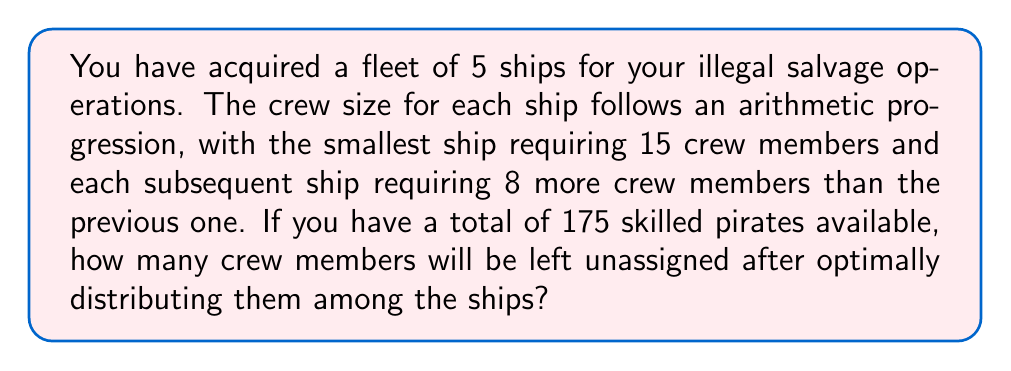Solve this math problem. Let's approach this step-by-step:

1) First, we need to determine the crew size for each ship using the arithmetic progression formula:
   $a_n = a_1 + (n-1)d$
   where $a_1 = 15$ (first term), $d = 8$ (common difference), and $n = 1,2,3,4,5$

2) Calculating crew sizes:
   Ship 1: $a_1 = 15$
   Ship 2: $a_2 = 15 + (2-1)8 = 23$
   Ship 3: $a_3 = 15 + (3-1)8 = 31$
   Ship 4: $a_4 = 15 + (4-1)8 = 39$
   Ship 5: $a_5 = 15 + (5-1)8 = 47$

3) To find the total number of crew members needed, we sum these values:
   $S_n = \frac{n}{2}(a_1 + a_n)$
   where $n = 5$, $a_1 = 15$, and $a_n = a_5 = 47$

4) Plugging in the values:
   $S_5 = \frac{5}{2}(15 + 47) = \frac{5}{2}(62) = 155$

5) Total available pirates: 175
   Total required for ships: 155
   
6) Unassigned crew members: $175 - 155 = 20$
Answer: 20 